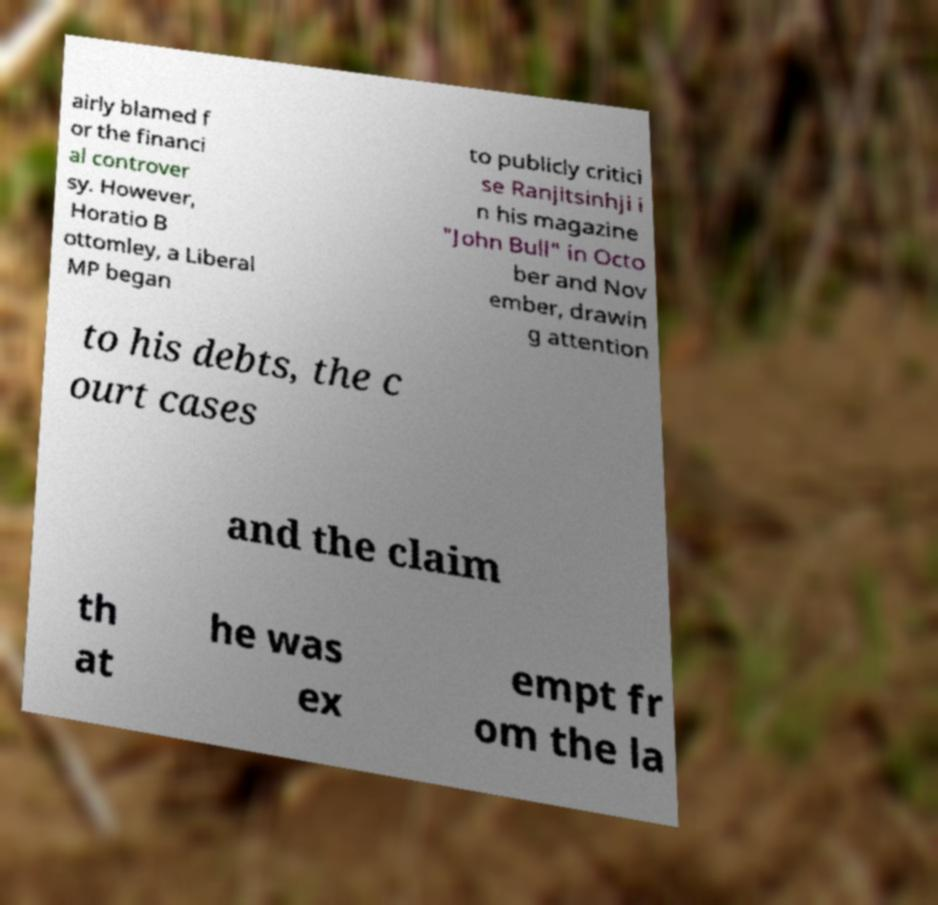Can you read and provide the text displayed in the image?This photo seems to have some interesting text. Can you extract and type it out for me? airly blamed f or the financi al controver sy. However, Horatio B ottomley, a Liberal MP began to publicly critici se Ranjitsinhji i n his magazine "John Bull" in Octo ber and Nov ember, drawin g attention to his debts, the c ourt cases and the claim th at he was ex empt fr om the la 